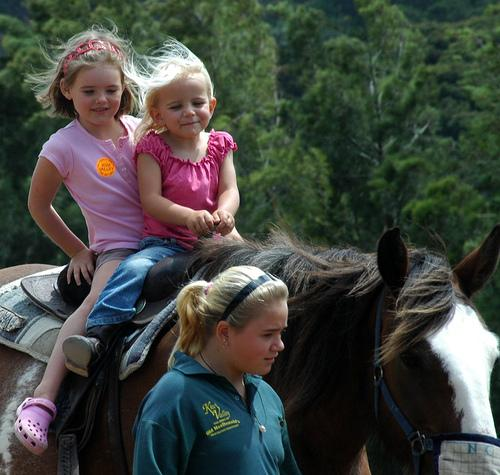What color is the person who is responsible for the safety of the two girls on horseback wearing? Please explain your reasoning. teal. An older adult is walking beside a horse as two young girls ride the horse. 